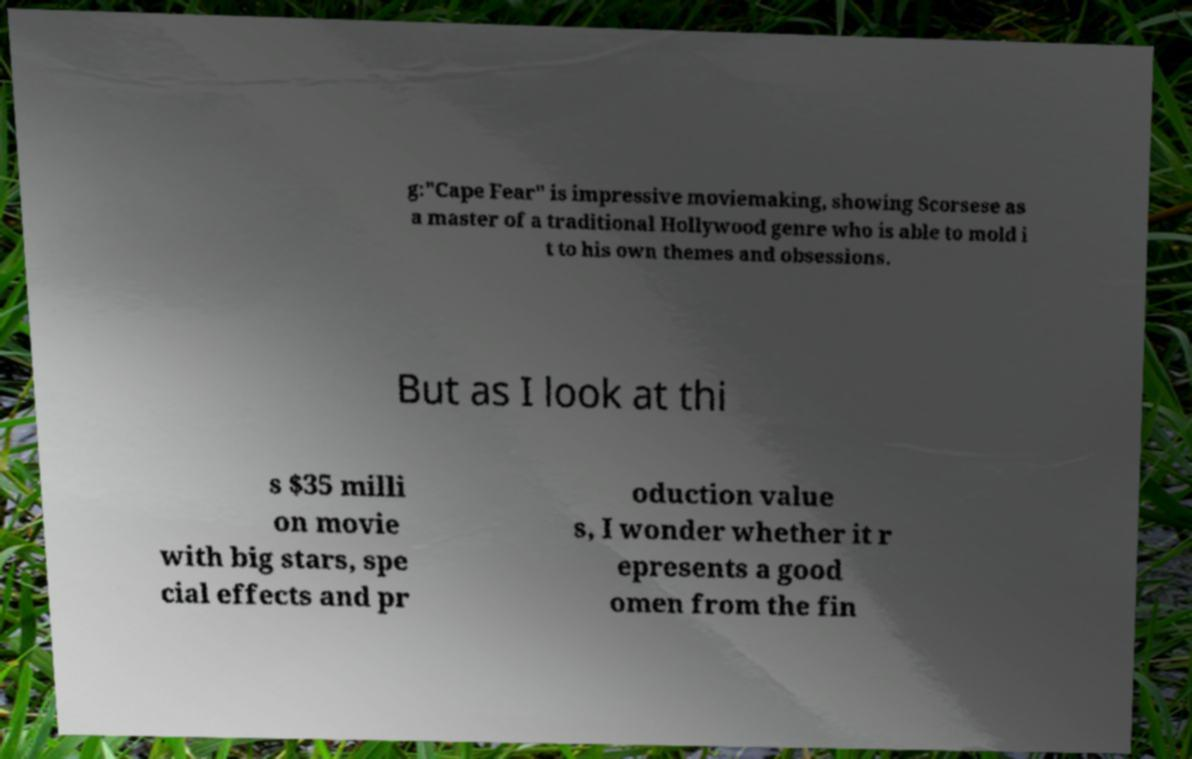There's text embedded in this image that I need extracted. Can you transcribe it verbatim? g:"Cape Fear" is impressive moviemaking, showing Scorsese as a master of a traditional Hollywood genre who is able to mold i t to his own themes and obsessions. But as I look at thi s $35 milli on movie with big stars, spe cial effects and pr oduction value s, I wonder whether it r epresents a good omen from the fin 